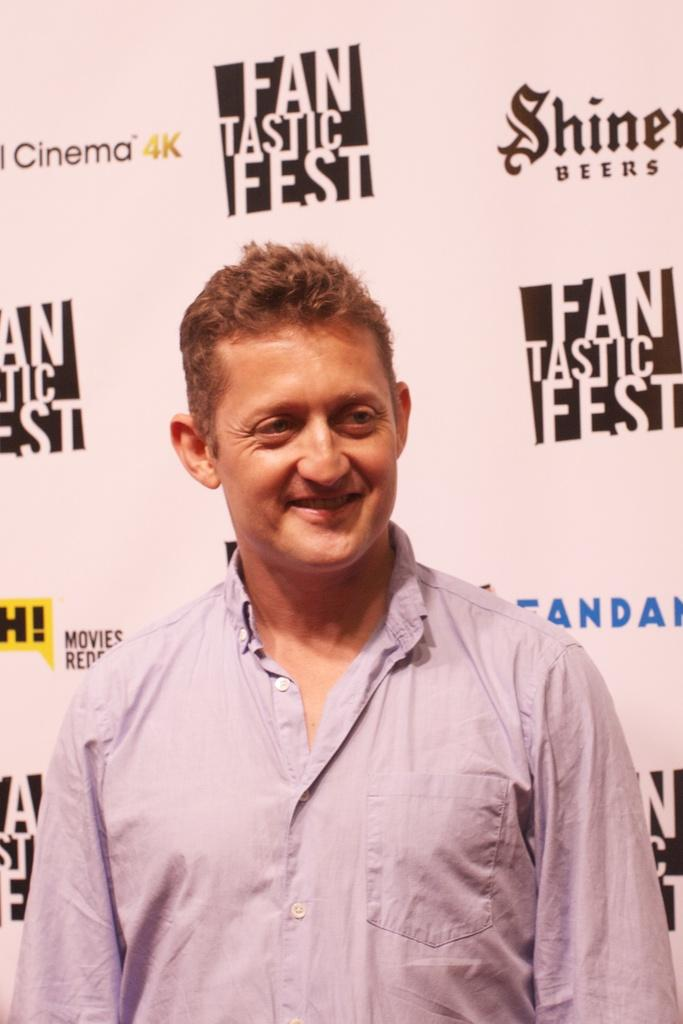<image>
Provide a brief description of the given image. A man stands in front of a wall for Fantastic Fest. 